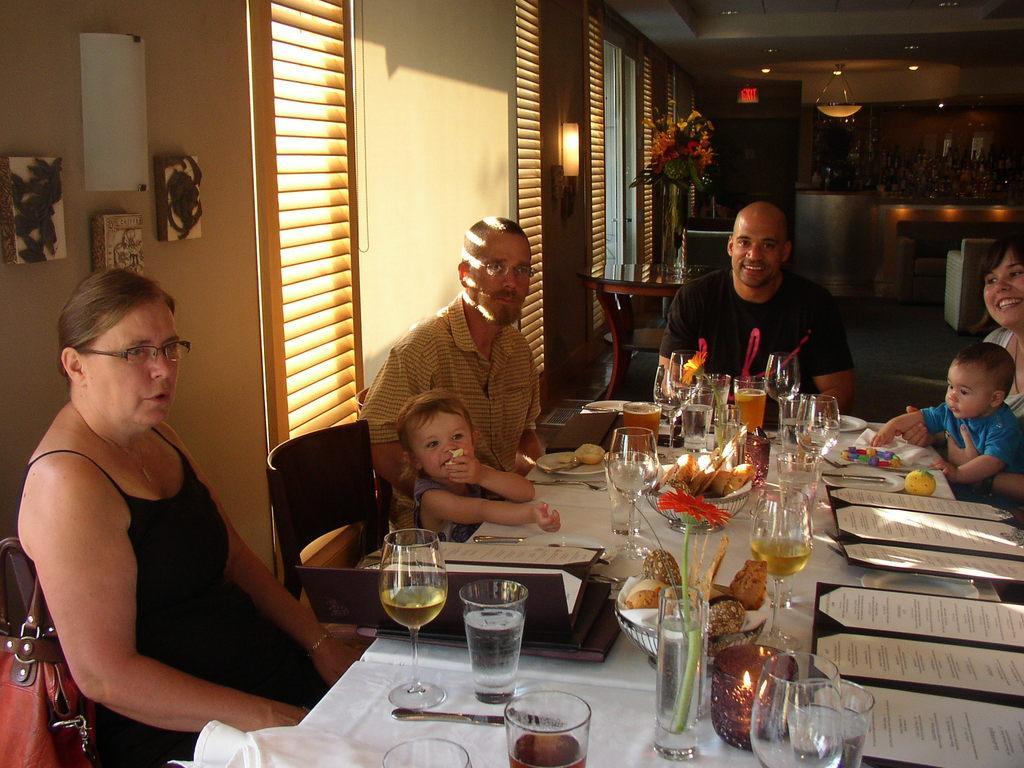Describe this image in one or two sentences. In this picture there is a woman sitting at the left side of image on chair which bag is hanged to it. Two persons and a boy is sitting at the middle of the image. A woman at the right side is holding a kid and smiling. There is a table at the front having glasses, flower, menu cards on the table. There is a flower vase and light hangs from the wall. There are few decorative show pieces attached to the wall at the left side of image. 